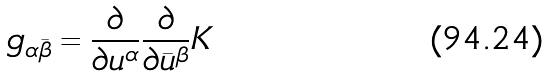Convert formula to latex. <formula><loc_0><loc_0><loc_500><loc_500>g _ { \alpha \bar { \beta } } = \frac { \partial } { \partial u ^ { \alpha } } \frac { \partial } { \partial \bar { u } ^ { \beta } } K</formula> 